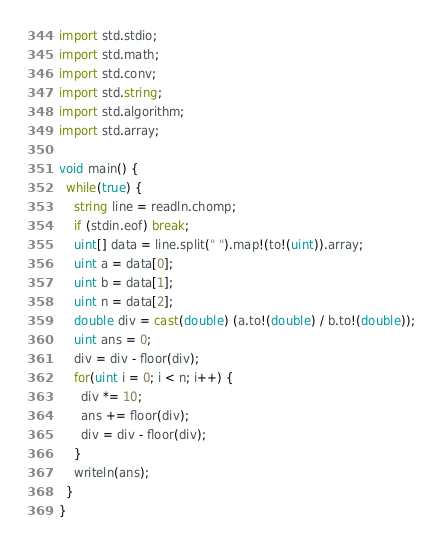<code> <loc_0><loc_0><loc_500><loc_500><_D_>
import std.stdio;
import std.math;
import std.conv;
import std.string;
import std.algorithm;
import std.array;

void main() {
  while(true) {
    string line = readln.chomp;
    if (stdin.eof) break;
    uint[] data = line.split(" ").map!(to!(uint)).array;
    uint a = data[0];
    uint b = data[1];
    uint n = data[2];
    double div = cast(double) (a.to!(double) / b.to!(double));
    uint ans = 0;
    div = div - floor(div);
    for(uint i = 0; i < n; i++) {
      div *= 10;
      ans += floor(div);
      div = div - floor(div);
    }
    writeln(ans);
  }
}</code> 